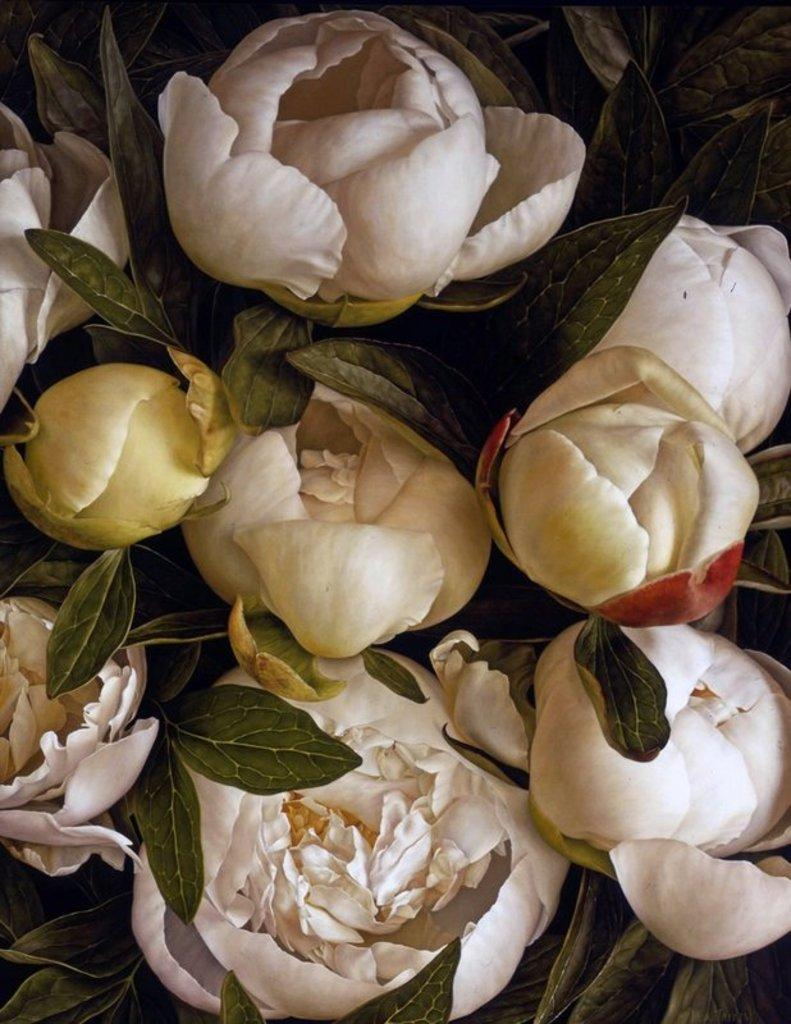What is the main subject in the center of the image? There are flowers and leaves in the center of the image. Can you describe the flowers in the image? Unfortunately, the facts provided do not give specific details about the flowers. What type of leaves are present in the image? The facts provided do not give specific details about the leaves. What type of trouble is the person experiencing on their vacation in the image? There is no person or indication of trouble or vacation in the image; it features flowers and leaves. 